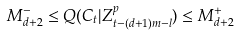<formula> <loc_0><loc_0><loc_500><loc_500>M _ { d + 2 } ^ { - } \leq Q ( C _ { t } | Z _ { t - ( d + 1 ) m - l } ^ { p } ) \leq M _ { d + 2 } ^ { + }</formula> 